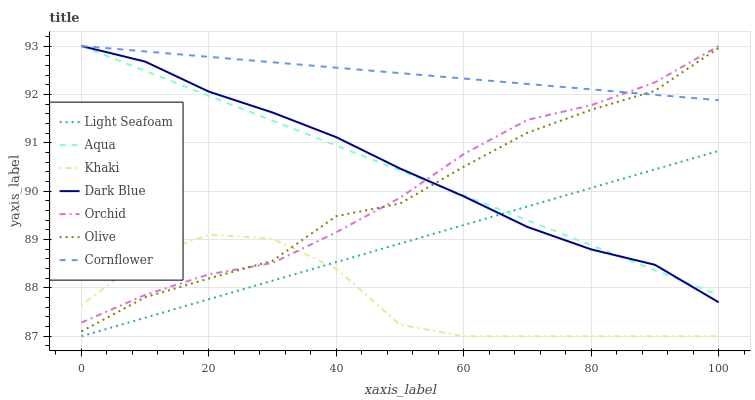Does Khaki have the minimum area under the curve?
Answer yes or no. Yes. Does Cornflower have the maximum area under the curve?
Answer yes or no. Yes. Does Aqua have the minimum area under the curve?
Answer yes or no. No. Does Aqua have the maximum area under the curve?
Answer yes or no. No. Is Cornflower the smoothest?
Answer yes or no. Yes. Is Khaki the roughest?
Answer yes or no. Yes. Is Aqua the smoothest?
Answer yes or no. No. Is Aqua the roughest?
Answer yes or no. No. Does Khaki have the lowest value?
Answer yes or no. Yes. Does Aqua have the lowest value?
Answer yes or no. No. Does Orchid have the highest value?
Answer yes or no. Yes. Does Khaki have the highest value?
Answer yes or no. No. Is Khaki less than Cornflower?
Answer yes or no. Yes. Is Dark Blue greater than Khaki?
Answer yes or no. Yes. Does Orchid intersect Olive?
Answer yes or no. Yes. Is Orchid less than Olive?
Answer yes or no. No. Is Orchid greater than Olive?
Answer yes or no. No. Does Khaki intersect Cornflower?
Answer yes or no. No. 